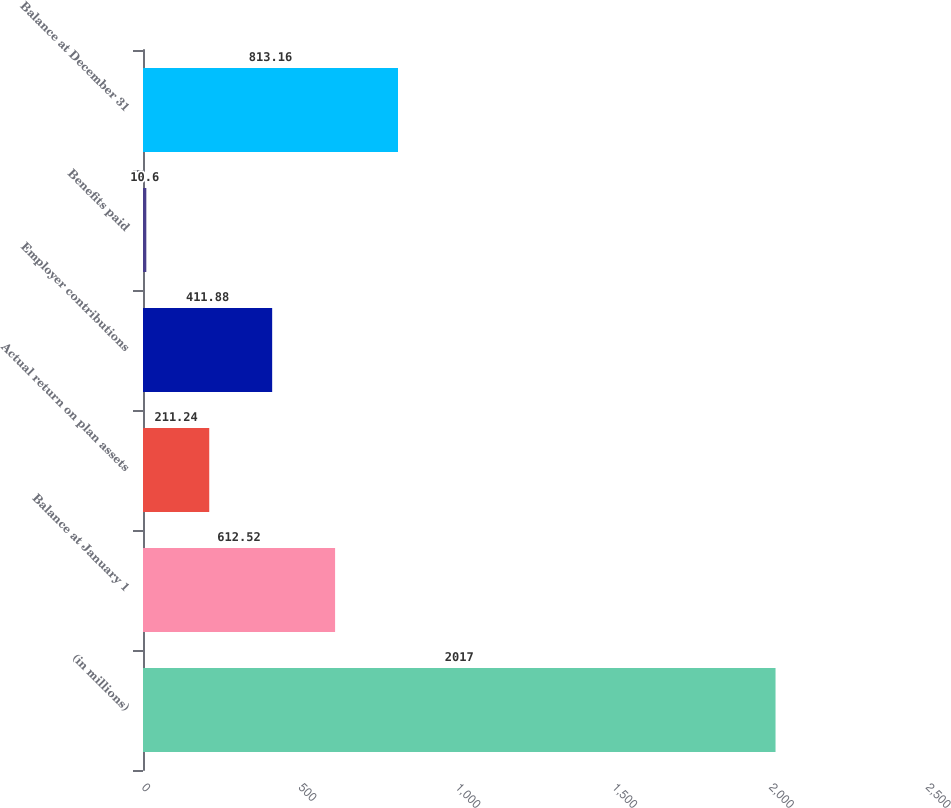<chart> <loc_0><loc_0><loc_500><loc_500><bar_chart><fcel>(in millions)<fcel>Balance at January 1<fcel>Actual return on plan assets<fcel>Employer contributions<fcel>Benefits paid<fcel>Balance at December 31<nl><fcel>2017<fcel>612.52<fcel>211.24<fcel>411.88<fcel>10.6<fcel>813.16<nl></chart> 